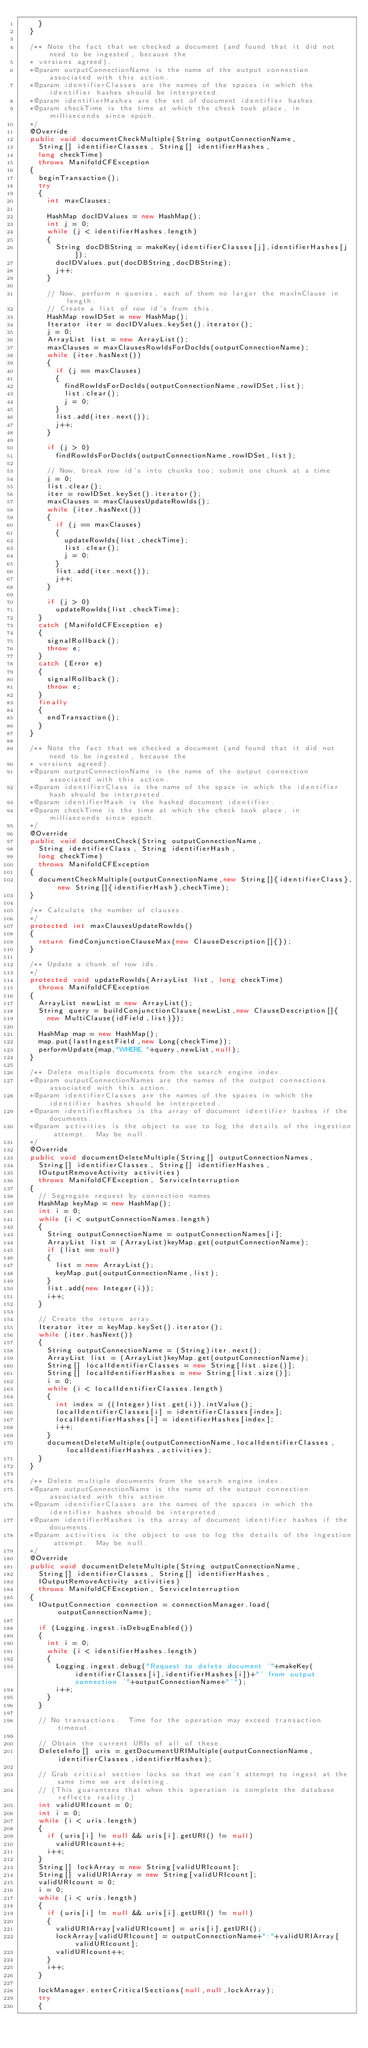Convert code to text. <code><loc_0><loc_0><loc_500><loc_500><_Java_>    }
  }

  /** Note the fact that we checked a document (and found that it did not need to be ingested, because the
  * versions agreed).
  *@param outputConnectionName is the name of the output connection associated with this action.
  *@param identifierClasses are the names of the spaces in which the identifier hashes should be interpreted.
  *@param identifierHashes are the set of document identifier hashes.
  *@param checkTime is the time at which the check took place, in milliseconds since epoch.
  */
  @Override
  public void documentCheckMultiple(String outputConnectionName,
    String[] identifierClasses, String[] identifierHashes,
    long checkTime)
    throws ManifoldCFException
  {
    beginTransaction();
    try
    {
      int maxClauses;
      
      HashMap docIDValues = new HashMap();
      int j = 0;
      while (j < identifierHashes.length)
      {
        String docDBString = makeKey(identifierClasses[j],identifierHashes[j]);
        docIDValues.put(docDBString,docDBString);
        j++;
      }

      // Now, perform n queries, each of them no larger the maxInClause in length.
      // Create a list of row id's from this.
      HashMap rowIDSet = new HashMap();
      Iterator iter = docIDValues.keySet().iterator();
      j = 0;
      ArrayList list = new ArrayList();
      maxClauses = maxClausesRowIdsForDocIds(outputConnectionName);
      while (iter.hasNext())
      {
        if (j == maxClauses)
        {
          findRowIdsForDocIds(outputConnectionName,rowIDSet,list);
          list.clear();
          j = 0;
        }
        list.add(iter.next());
        j++;
      }

      if (j > 0)
        findRowIdsForDocIds(outputConnectionName,rowIDSet,list);

      // Now, break row id's into chunks too; submit one chunk at a time
      j = 0;
      list.clear();
      iter = rowIDSet.keySet().iterator();
      maxClauses = maxClausesUpdateRowIds();
      while (iter.hasNext())
      {
        if (j == maxClauses)
        {
          updateRowIds(list,checkTime);
          list.clear();
          j = 0;
        }
        list.add(iter.next());
        j++;
      }

      if (j > 0)
        updateRowIds(list,checkTime);
    }
    catch (ManifoldCFException e)
    {
      signalRollback();
      throw e;
    }
    catch (Error e)
    {
      signalRollback();
      throw e;
    }
    finally
    {
      endTransaction();
    }
  }

  /** Note the fact that we checked a document (and found that it did not need to be ingested, because the
  * versions agreed).
  *@param outputConnectionName is the name of the output connection associated with this action.
  *@param identifierClass is the name of the space in which the identifier hash should be interpreted.
  *@param identifierHash is the hashed document identifier.
  *@param checkTime is the time at which the check took place, in milliseconds since epoch.
  */
  @Override
  public void documentCheck(String outputConnectionName,
    String identifierClass, String identifierHash,
    long checkTime)
    throws ManifoldCFException
  {
    documentCheckMultiple(outputConnectionName,new String[]{identifierClass},new String[]{identifierHash},checkTime);
  }

  /** Calculate the number of clauses.
  */
  protected int maxClausesUpdateRowIds()
  {
    return findConjunctionClauseMax(new ClauseDescription[]{});
  }
  
  /** Update a chunk of row ids.
  */
  protected void updateRowIds(ArrayList list, long checkTime)
    throws ManifoldCFException
  {
    ArrayList newList = new ArrayList();
    String query = buildConjunctionClause(newList,new ClauseDescription[]{
      new MultiClause(idField,list)});
      
    HashMap map = new HashMap();
    map.put(lastIngestField,new Long(checkTime));
    performUpdate(map,"WHERE "+query,newList,null);
  }

  /** Delete multiple documents from the search engine index.
  *@param outputConnectionNames are the names of the output connections associated with this action.
  *@param identifierClasses are the names of the spaces in which the identifier hashes should be interpreted.
  *@param identifierHashes is tha array of document identifier hashes if the documents.
  *@param activities is the object to use to log the details of the ingestion attempt.  May be null.
  */
  @Override
  public void documentDeleteMultiple(String[] outputConnectionNames,
    String[] identifierClasses, String[] identifierHashes,
    IOutputRemoveActivity activities)
    throws ManifoldCFException, ServiceInterruption
  {
    // Segregate request by connection names
    HashMap keyMap = new HashMap();
    int i = 0;
    while (i < outputConnectionNames.length)
    {
      String outputConnectionName = outputConnectionNames[i];
      ArrayList list = (ArrayList)keyMap.get(outputConnectionName);
      if (list == null)
      {
        list = new ArrayList();
        keyMap.put(outputConnectionName,list);
      }
      list.add(new Integer(i));
      i++;
    }

    // Create the return array.
    Iterator iter = keyMap.keySet().iterator();
    while (iter.hasNext())
    {
      String outputConnectionName = (String)iter.next();
      ArrayList list = (ArrayList)keyMap.get(outputConnectionName);
      String[] localIdentifierClasses = new String[list.size()];
      String[] localIdentifierHashes = new String[list.size()];
      i = 0;
      while (i < localIdentifierClasses.length)
      {
        int index = ((Integer)list.get(i)).intValue();
        localIdentifierClasses[i] = identifierClasses[index];
        localIdentifierHashes[i] = identifierHashes[index];
        i++;
      }
      documentDeleteMultiple(outputConnectionName,localIdentifierClasses,localIdentifierHashes,activities);
    }
  }

  /** Delete multiple documents from the search engine index.
  *@param outputConnectionName is the name of the output connection associated with this action.
  *@param identifierClasses are the names of the spaces in which the identifier hashes should be interpreted.
  *@param identifierHashes is tha array of document identifier hashes if the documents.
  *@param activities is the object to use to log the details of the ingestion attempt.  May be null.
  */
  @Override
  public void documentDeleteMultiple(String outputConnectionName,
    String[] identifierClasses, String[] identifierHashes,
    IOutputRemoveActivity activities)
    throws ManifoldCFException, ServiceInterruption
  {
    IOutputConnection connection = connectionManager.load(outputConnectionName);

    if (Logging.ingest.isDebugEnabled())
    {
      int i = 0;
      while (i < identifierHashes.length)
      {
        Logging.ingest.debug("Request to delete document '"+makeKey(identifierClasses[i],identifierHashes[i])+"' from output connection '"+outputConnectionName+"'");
        i++;
      }
    }

    // No transactions.  Time for the operation may exceed transaction timeout.

    // Obtain the current URIs of all of these.
    DeleteInfo[] uris = getDocumentURIMultiple(outputConnectionName,identifierClasses,identifierHashes);

    // Grab critical section locks so that we can't attempt to ingest at the same time we are deleting.
    // (This guarantees that when this operation is complete the database reflects reality.)
    int validURIcount = 0;
    int i = 0;
    while (i < uris.length)
    {
      if (uris[i] != null && uris[i].getURI() != null)
        validURIcount++;
      i++;
    }
    String[] lockArray = new String[validURIcount];
    String[] validURIArray = new String[validURIcount];
    validURIcount = 0;
    i = 0;
    while (i < uris.length)
    {
      if (uris[i] != null && uris[i].getURI() != null)
      {
        validURIArray[validURIcount] = uris[i].getURI();
        lockArray[validURIcount] = outputConnectionName+":"+validURIArray[validURIcount];
        validURIcount++;
      }
      i++;
    }

    lockManager.enterCriticalSections(null,null,lockArray);
    try
    {</code> 